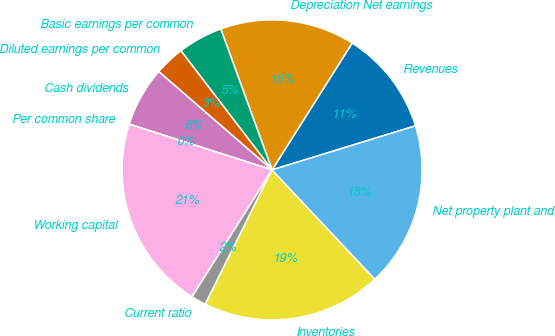<chart> <loc_0><loc_0><loc_500><loc_500><pie_chart><fcel>Revenues<fcel>Depreciation Net earnings<fcel>Basic earnings per common<fcel>Diluted earnings per common<fcel>Cash dividends<fcel>Per common share<fcel>Working capital<fcel>Current ratio<fcel>Inventories<fcel>Net property plant and<nl><fcel>11.29%<fcel>14.52%<fcel>4.84%<fcel>3.23%<fcel>6.45%<fcel>0.0%<fcel>20.97%<fcel>1.61%<fcel>19.35%<fcel>17.74%<nl></chart> 